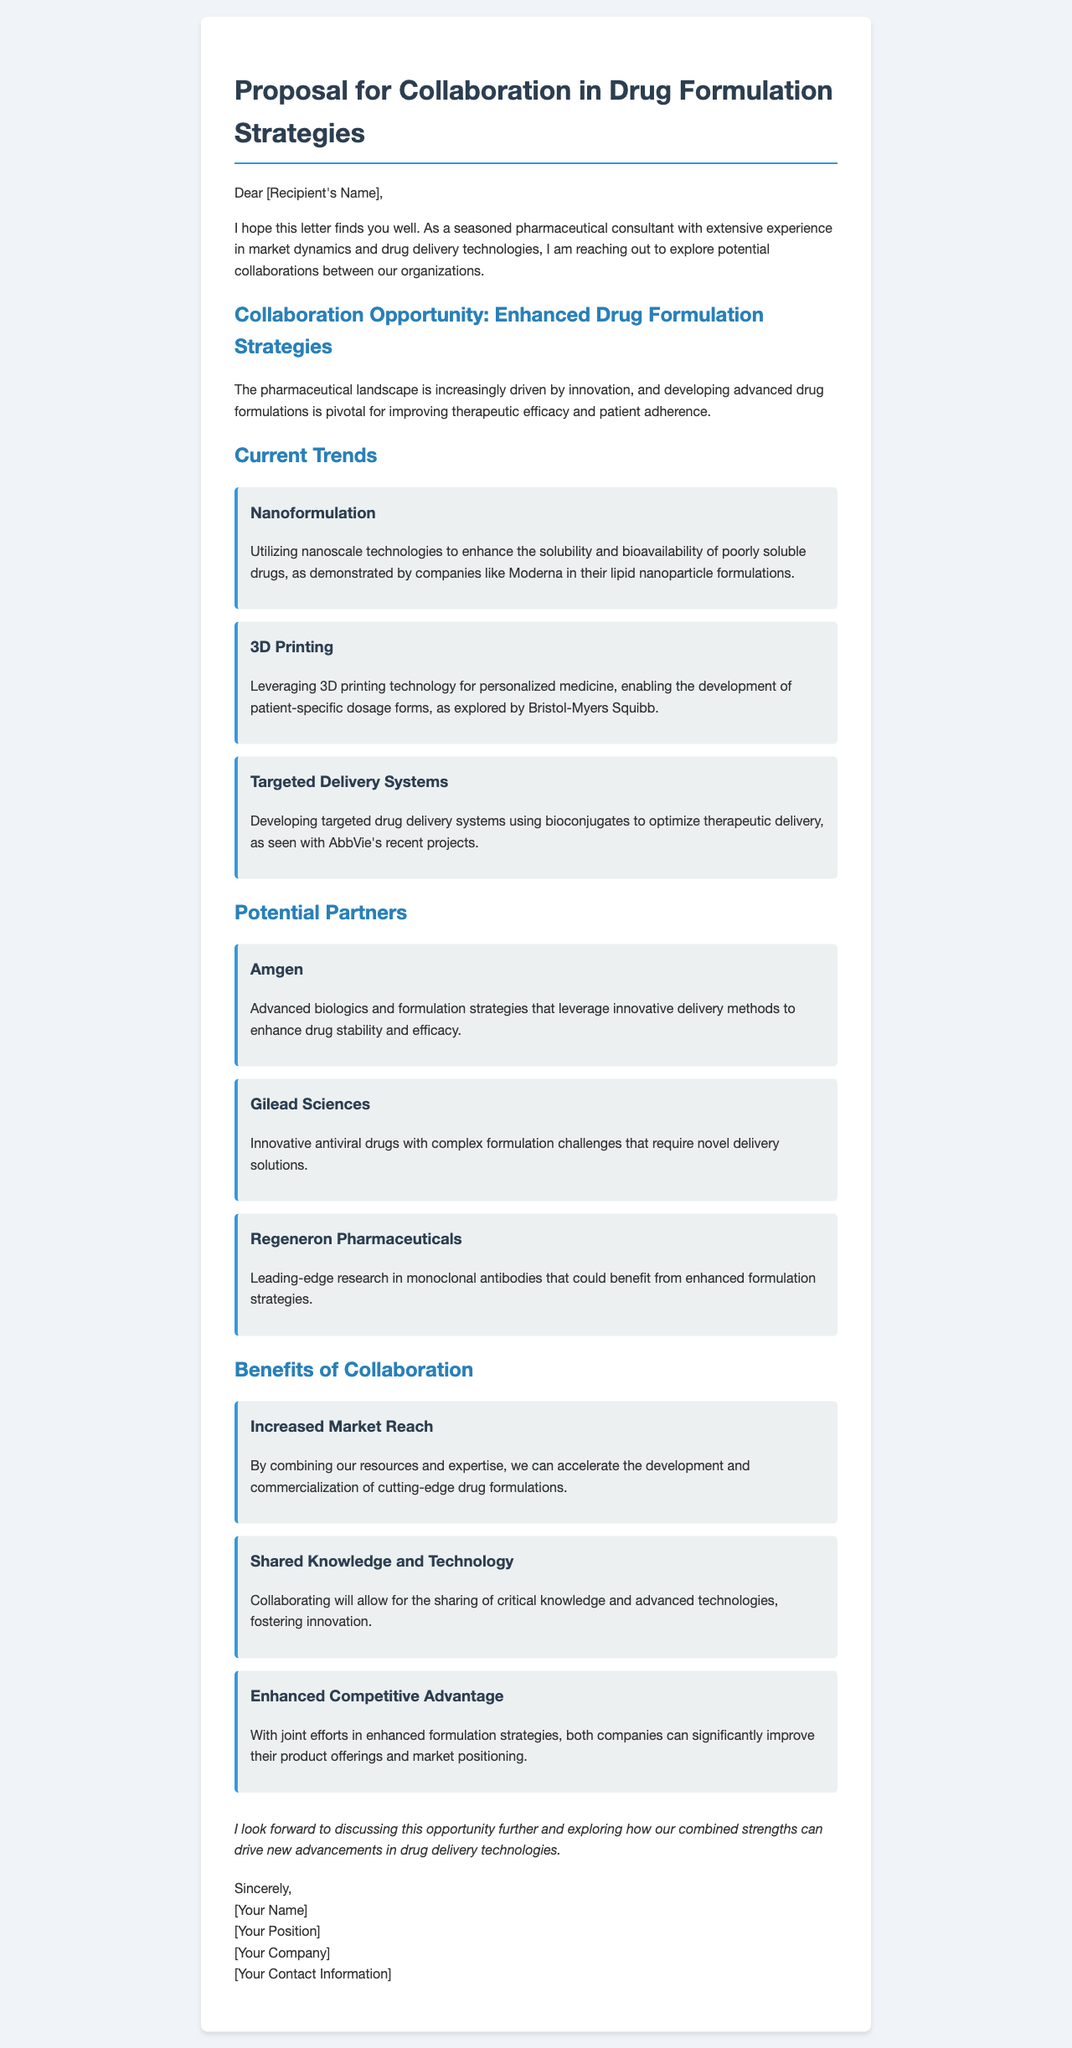what is the main purpose of the letter? The letter outlines a proposal for collaboration focusing on enhanced drug formulation strategies with biotech firms.
Answer: collaboration proposal who is the intended recipient of the letter? The letter addresses an unnamed individual referred to as [Recipient's Name].
Answer: [Recipient's Name] name one current trend mentioned in the document. The letter lists several current trends in drug formulation, including nanoformulation.
Answer: nanoformulation which company is associated with 3D printing technology? Bristol-Myers Squibb is mentioned in connection with 3D printing for personalized medicine.
Answer: Bristol-Myers Squibb what is one benefit of collaboration stated in the letter? The document lists benefits such as increased market reach, shared knowledge, and enhanced competitive advantage.
Answer: increased market reach how many potential partners are listed in the document? The letter details three potential partners for collaboration in enhanced drug formulation strategies.
Answer: three what technology does Amgen leverage according to the letter? Amgen utilizes advanced biologics and formulation strategies to enhance drug stability and efficacy.
Answer: advanced biologics which innovative area does Gilead Sciences focus on? Gilead Sciences is noted for its innovative antiviral drugs with complex formulation challenges.
Answer: antiviral drugs what is the closing sentiment expressed in the letter? The letter expresses a desire to discuss the collaboration opportunity further.
Answer: discuss collaboration further 